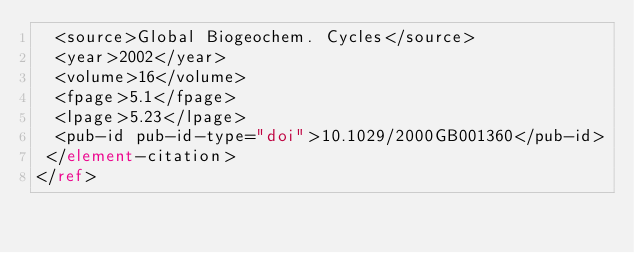Convert code to text. <code><loc_0><loc_0><loc_500><loc_500><_XML_>  <source>Global Biogeochem. Cycles</source>
  <year>2002</year>
  <volume>16</volume>
  <fpage>5.1</fpage>
  <lpage>5.23</lpage>
  <pub-id pub-id-type="doi">10.1029/2000GB001360</pub-id>
 </element-citation>
</ref>
</code> 